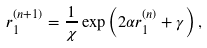Convert formula to latex. <formula><loc_0><loc_0><loc_500><loc_500>r _ { 1 } ^ { ( n + 1 ) } = \frac { 1 } { \chi } \exp \left ( 2 \alpha r _ { 1 } ^ { ( n ) } + \gamma \right ) ,</formula> 